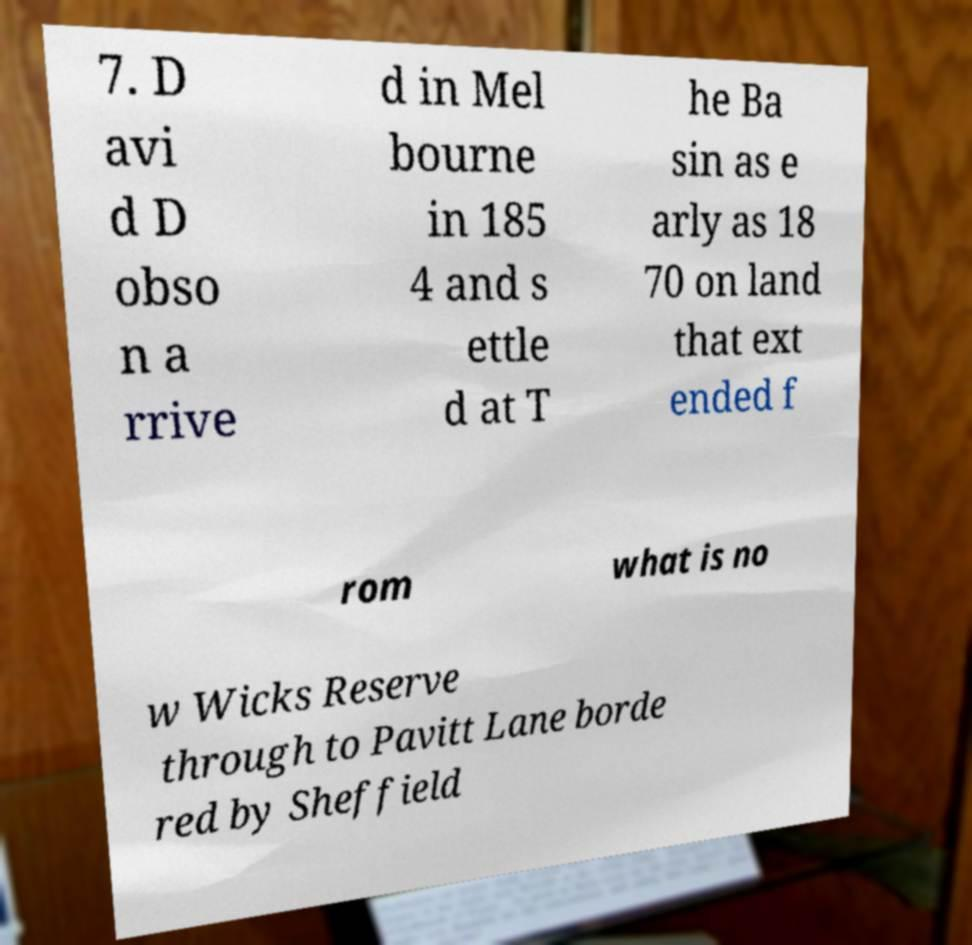For documentation purposes, I need the text within this image transcribed. Could you provide that? 7. D avi d D obso n a rrive d in Mel bourne in 185 4 and s ettle d at T he Ba sin as e arly as 18 70 on land that ext ended f rom what is no w Wicks Reserve through to Pavitt Lane borde red by Sheffield 